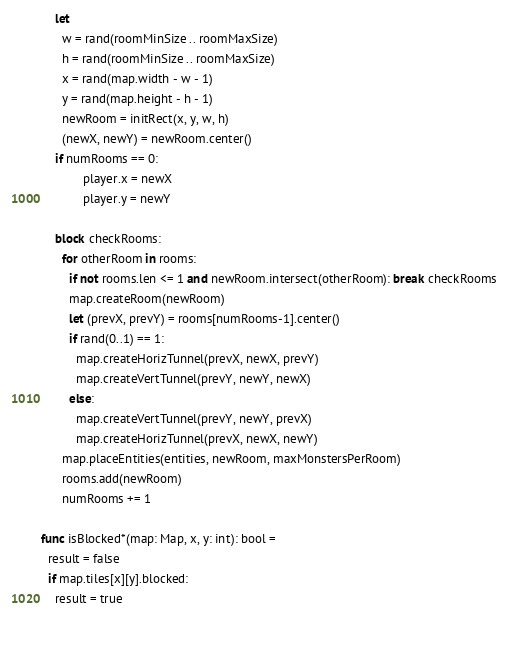<code> <loc_0><loc_0><loc_500><loc_500><_Nim_>    let
      w = rand(roomMinSize .. roomMaxSize)
      h = rand(roomMinSize .. roomMaxSize)
      x = rand(map.width - w - 1)
      y = rand(map.height - h - 1)
      newRoom = initRect(x, y, w, h)
      (newX, newY) = newRoom.center()
    if numRooms == 0:
            player.x = newX
            player.y = newY
    
    block checkRooms:
      for otherRoom in rooms:
        if not rooms.len <= 1 and newRoom.intersect(otherRoom): break checkRooms
        map.createRoom(newRoom)
        let (prevX, prevY) = rooms[numRooms-1].center()
        if rand(0..1) == 1:
          map.createHorizTunnel(prevX, newX, prevY)
          map.createVertTunnel(prevY, newY, newX)
        else:
          map.createVertTunnel(prevY, newY, prevX)
          map.createHorizTunnel(prevX, newX, newY)
      map.placeEntities(entities, newRoom, maxMonstersPerRoom)
      rooms.add(newRoom)
      numRooms += 1  
  
func isBlocked*(map: Map, x, y: int): bool =
  result = false
  if map.tiles[x][y].blocked:
    result = true

  </code> 